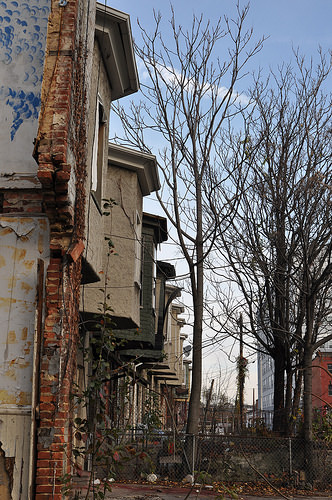<image>
Is the building to the right of the tree? No. The building is not to the right of the tree. The horizontal positioning shows a different relationship. 